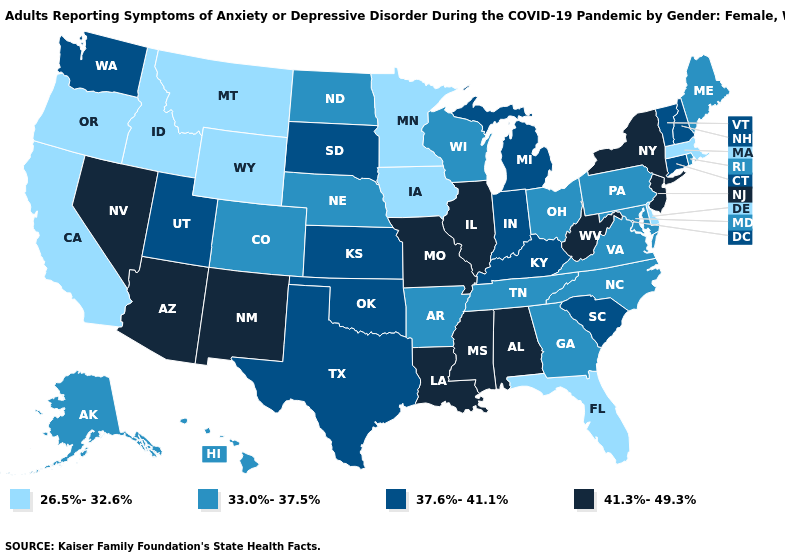Does New Jersey have the highest value in the Northeast?
Keep it brief. Yes. Name the states that have a value in the range 37.6%-41.1%?
Be succinct. Connecticut, Indiana, Kansas, Kentucky, Michigan, New Hampshire, Oklahoma, South Carolina, South Dakota, Texas, Utah, Vermont, Washington. Among the states that border Kansas , does Colorado have the highest value?
Short answer required. No. What is the highest value in states that border Nevada?
Write a very short answer. 41.3%-49.3%. Among the states that border Tennessee , does Alabama have the highest value?
Be succinct. Yes. What is the value of Virginia?
Answer briefly. 33.0%-37.5%. Name the states that have a value in the range 33.0%-37.5%?
Quick response, please. Alaska, Arkansas, Colorado, Georgia, Hawaii, Maine, Maryland, Nebraska, North Carolina, North Dakota, Ohio, Pennsylvania, Rhode Island, Tennessee, Virginia, Wisconsin. Does Tennessee have the same value as Georgia?
Keep it brief. Yes. Name the states that have a value in the range 37.6%-41.1%?
Be succinct. Connecticut, Indiana, Kansas, Kentucky, Michigan, New Hampshire, Oklahoma, South Carolina, South Dakota, Texas, Utah, Vermont, Washington. What is the highest value in states that border Idaho?
Answer briefly. 41.3%-49.3%. Does Oklahoma have a higher value than Mississippi?
Give a very brief answer. No. Which states have the highest value in the USA?
Short answer required. Alabama, Arizona, Illinois, Louisiana, Mississippi, Missouri, Nevada, New Jersey, New Mexico, New York, West Virginia. Name the states that have a value in the range 41.3%-49.3%?
Concise answer only. Alabama, Arizona, Illinois, Louisiana, Mississippi, Missouri, Nevada, New Jersey, New Mexico, New York, West Virginia. Which states have the lowest value in the USA?
Keep it brief. California, Delaware, Florida, Idaho, Iowa, Massachusetts, Minnesota, Montana, Oregon, Wyoming. Does Arkansas have a lower value than Connecticut?
Short answer required. Yes. 